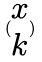Convert formula to latex. <formula><loc_0><loc_0><loc_500><loc_500>( \begin{matrix} x \\ k \end{matrix} )</formula> 